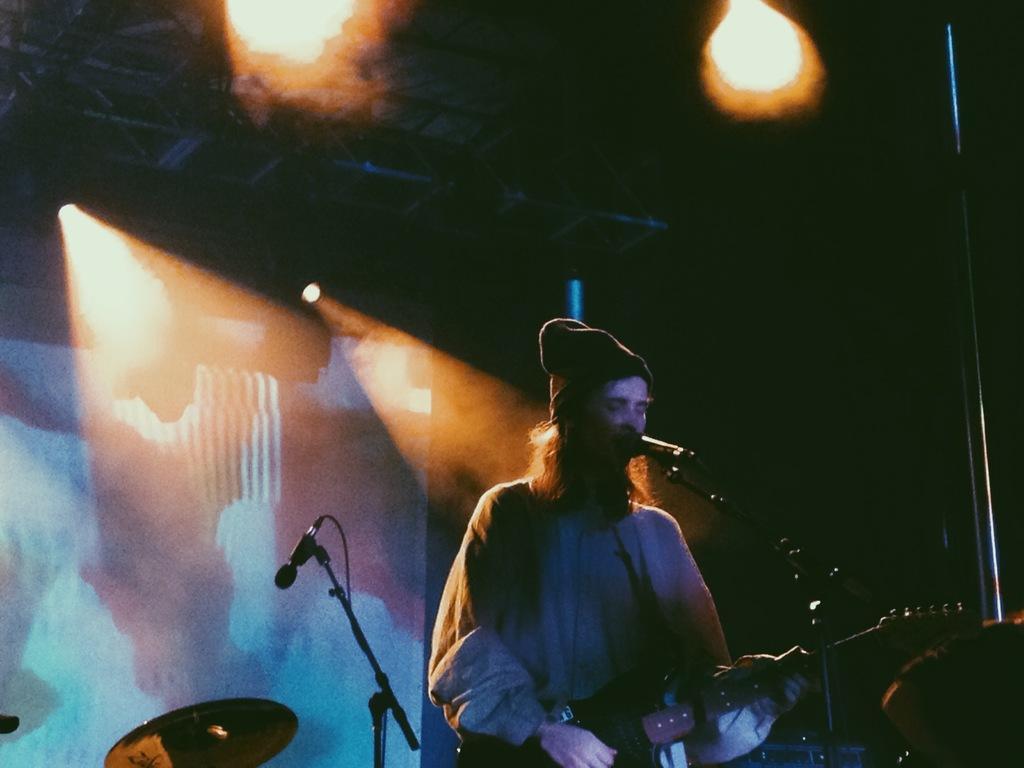Please provide a concise description of this image. In this image we can see a person playing a guitar. There is a mic. In the background of the image there is a screen. At the top of the image there are lights. 